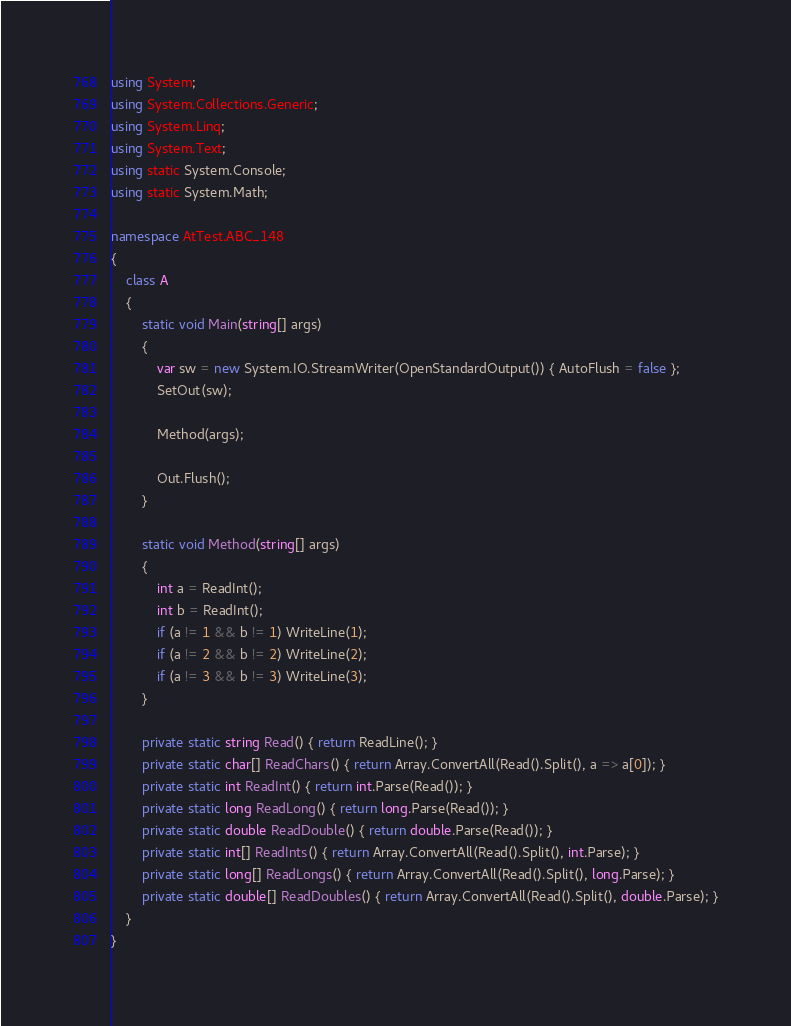Convert code to text. <code><loc_0><loc_0><loc_500><loc_500><_C#_>using System;
using System.Collections.Generic;
using System.Linq;
using System.Text;
using static System.Console;
using static System.Math;

namespace AtTest.ABC_148
{
    class A
    {
        static void Main(string[] args)
        {
            var sw = new System.IO.StreamWriter(OpenStandardOutput()) { AutoFlush = false };
            SetOut(sw);

            Method(args);

            Out.Flush();
        }

        static void Method(string[] args)
        {
            int a = ReadInt();
            int b = ReadInt();
            if (a != 1 && b != 1) WriteLine(1);
            if (a != 2 && b != 2) WriteLine(2);
            if (a != 3 && b != 3) WriteLine(3);
        }

        private static string Read() { return ReadLine(); }
        private static char[] ReadChars() { return Array.ConvertAll(Read().Split(), a => a[0]); }
        private static int ReadInt() { return int.Parse(Read()); }
        private static long ReadLong() { return long.Parse(Read()); }
        private static double ReadDouble() { return double.Parse(Read()); }
        private static int[] ReadInts() { return Array.ConvertAll(Read().Split(), int.Parse); }
        private static long[] ReadLongs() { return Array.ConvertAll(Read().Split(), long.Parse); }
        private static double[] ReadDoubles() { return Array.ConvertAll(Read().Split(), double.Parse); }
    }
}
</code> 